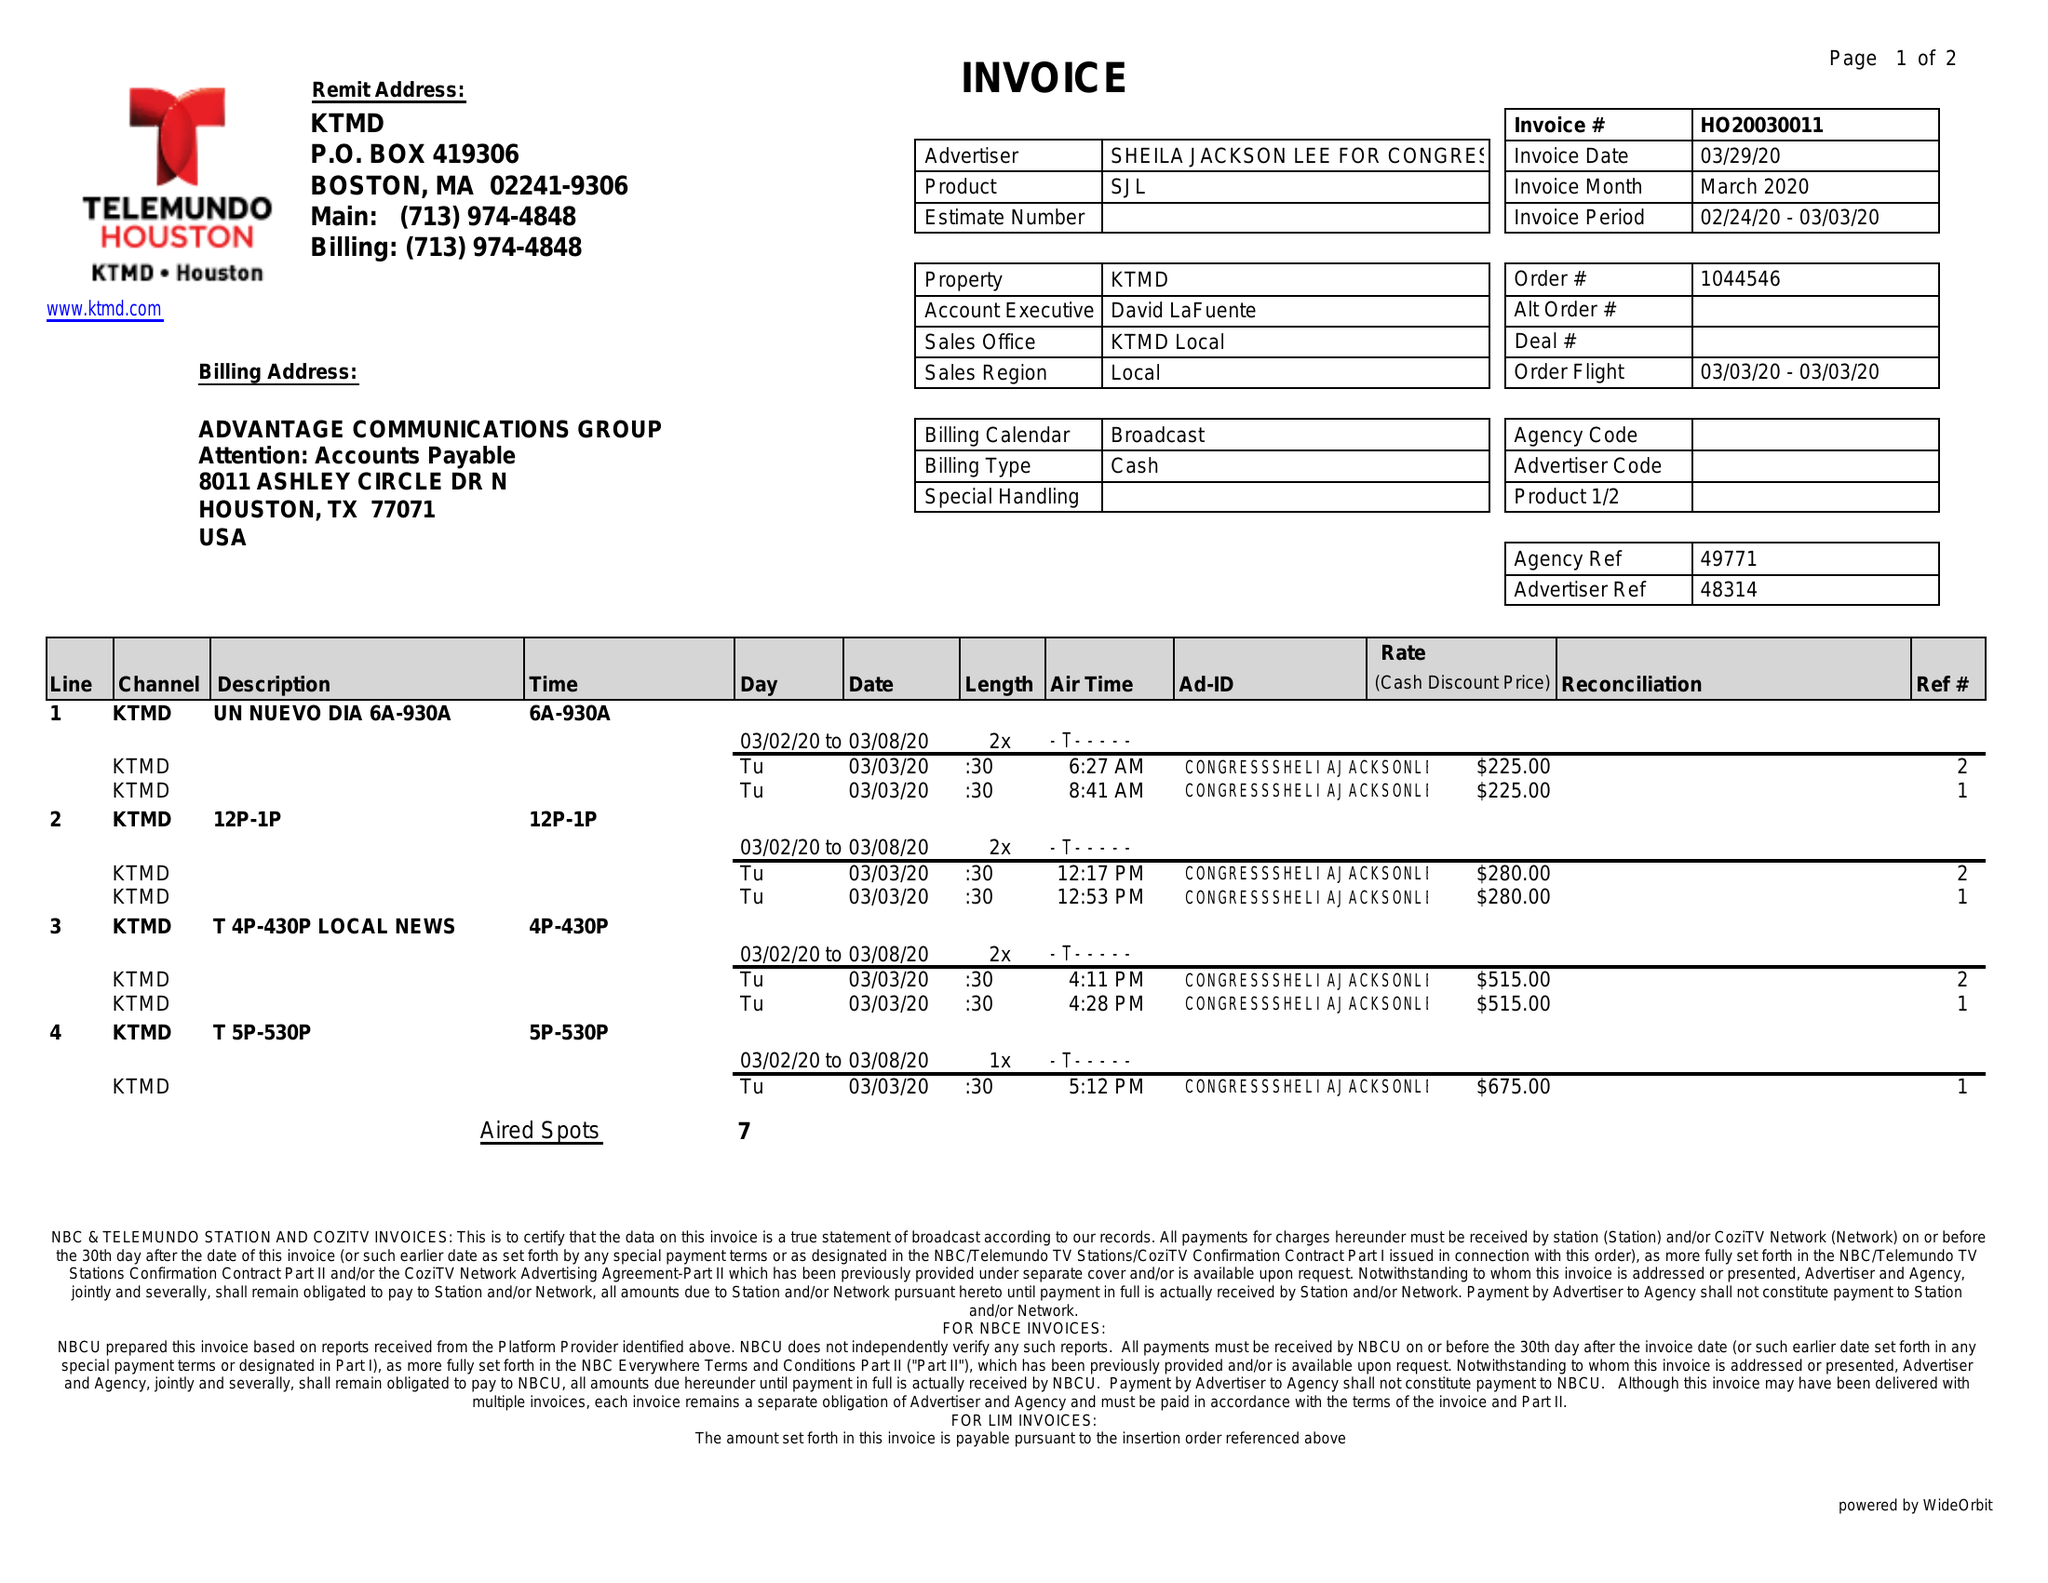What is the value for the gross_amount?
Answer the question using a single word or phrase. 2715.00 